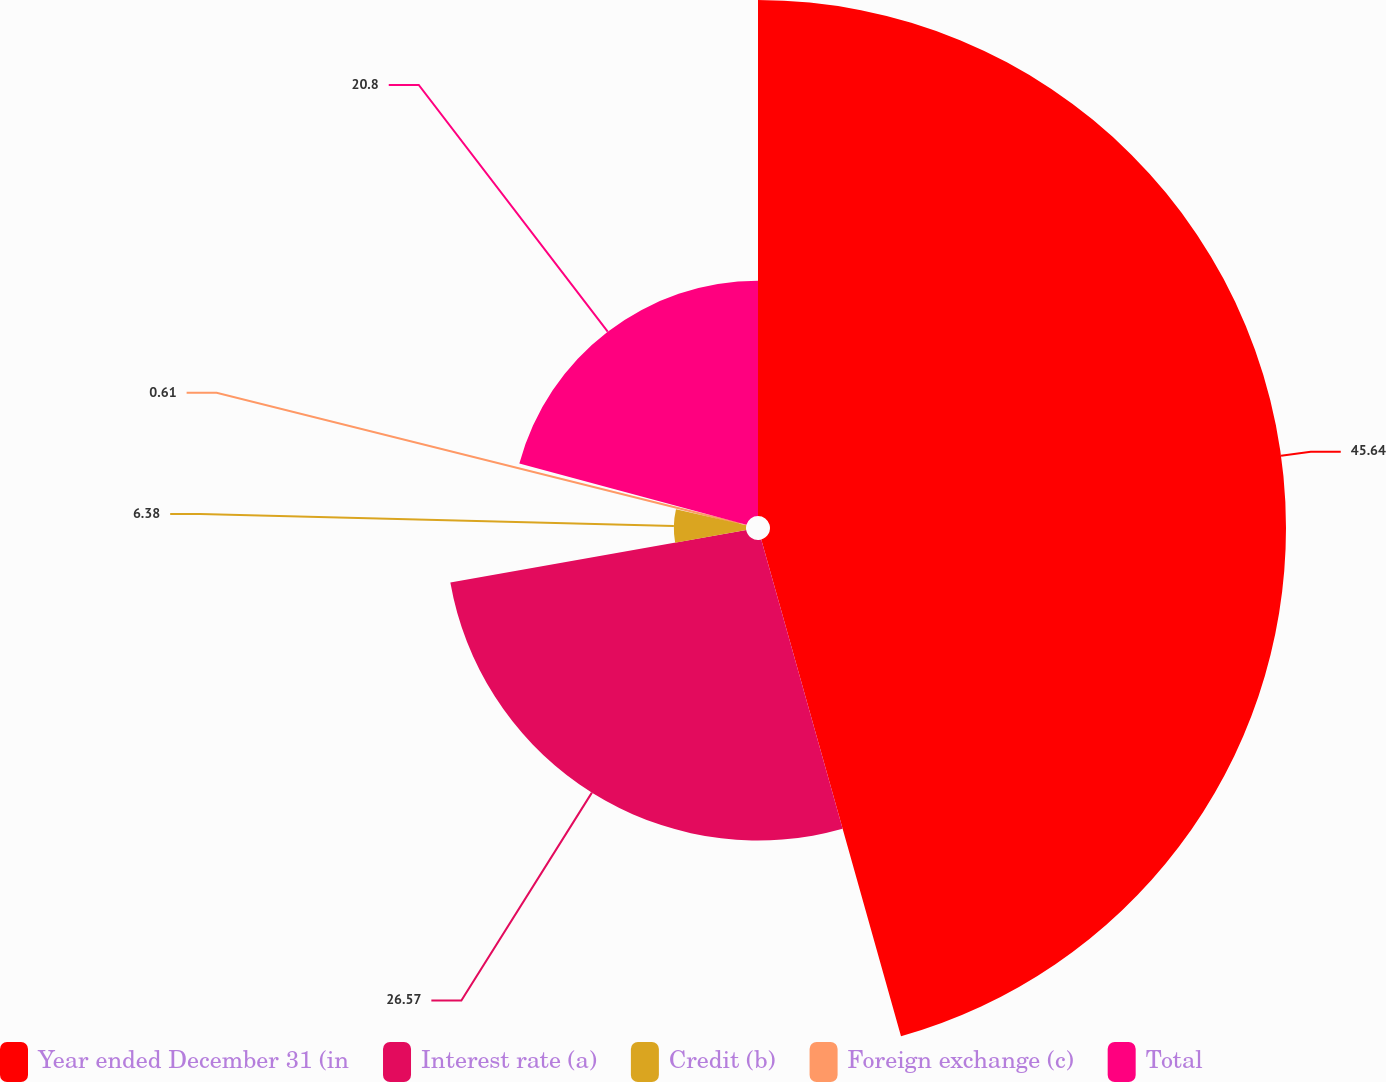Convert chart to OTSL. <chart><loc_0><loc_0><loc_500><loc_500><pie_chart><fcel>Year ended December 31 (in<fcel>Interest rate (a)<fcel>Credit (b)<fcel>Foreign exchange (c)<fcel>Total<nl><fcel>45.63%<fcel>26.57%<fcel>6.38%<fcel>0.61%<fcel>20.8%<nl></chart> 